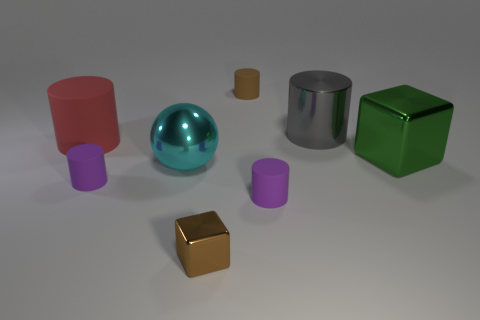Is the number of big shiny balls right of the brown cube the same as the number of green things behind the large red thing?
Make the answer very short. Yes. There is a block that is behind the tiny block; does it have the same color as the block in front of the large cyan shiny ball?
Your answer should be very brief. No. Are there more big metal things behind the big ball than green things?
Offer a very short reply. Yes. There is a small brown object that is made of the same material as the green cube; what shape is it?
Provide a succinct answer. Cube. Does the metallic cube that is on the left side of the green cube have the same size as the green thing?
Make the answer very short. No. There is a tiny brown object in front of the tiny rubber cylinder that is behind the big block; what shape is it?
Offer a very short reply. Cube. There is a purple rubber object that is in front of the purple rubber thing that is to the left of the small brown matte cylinder; how big is it?
Your answer should be very brief. Small. There is a shiny thing behind the big green block; what is its color?
Your answer should be compact. Gray. What is the size of the ball that is the same material as the green object?
Provide a short and direct response. Large. What number of brown rubber things have the same shape as the red rubber thing?
Give a very brief answer. 1. 